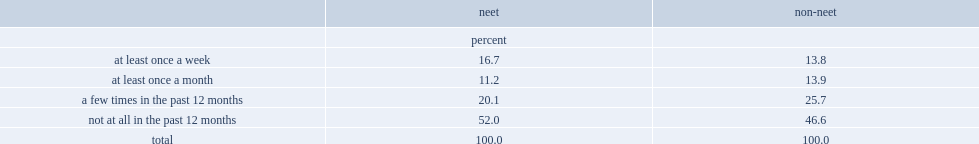What percent of the neet population provided this type of help in the past 12 months? 48. What percent of the non-neet population provided this type of help in the past 12 months. 53.4. 